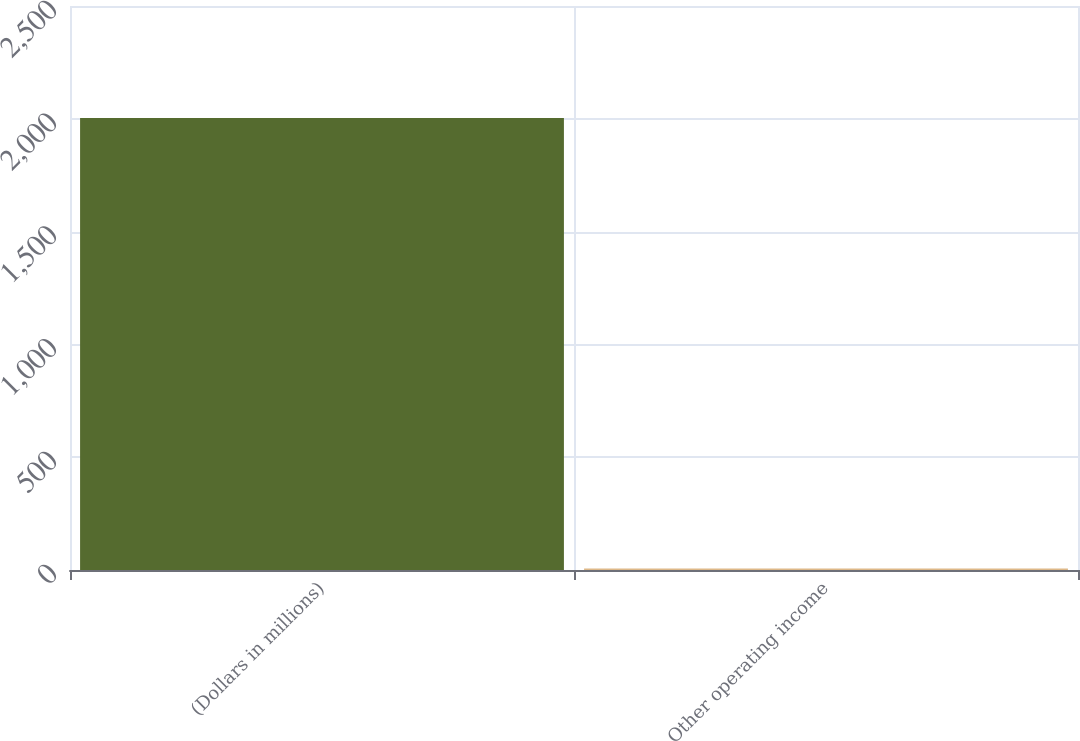Convert chart. <chart><loc_0><loc_0><loc_500><loc_500><bar_chart><fcel>(Dollars in millions)<fcel>Other operating income<nl><fcel>2004<fcel>7<nl></chart> 